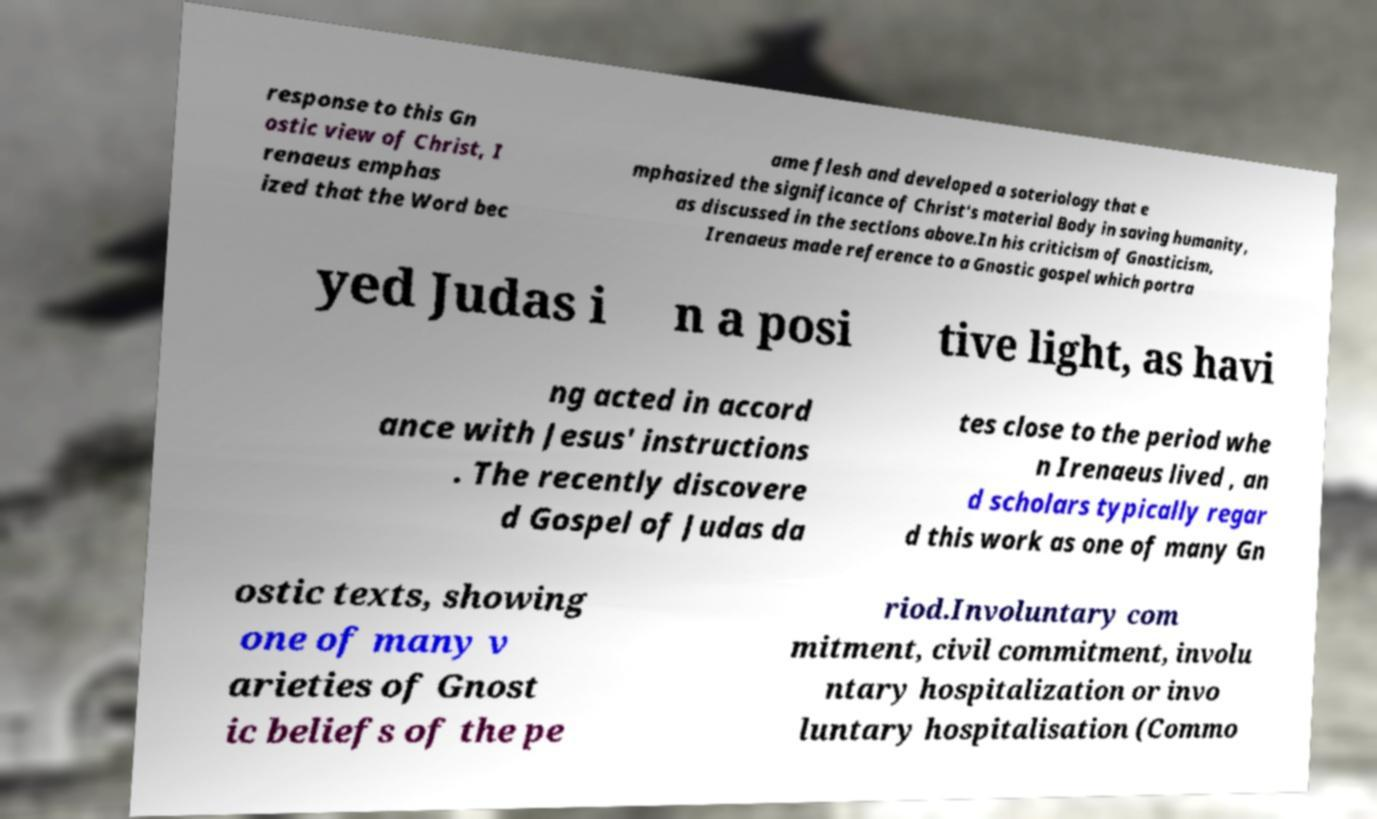I need the written content from this picture converted into text. Can you do that? response to this Gn ostic view of Christ, I renaeus emphas ized that the Word bec ame flesh and developed a soteriology that e mphasized the significance of Christ's material Body in saving humanity, as discussed in the sections above.In his criticism of Gnosticism, Irenaeus made reference to a Gnostic gospel which portra yed Judas i n a posi tive light, as havi ng acted in accord ance with Jesus' instructions . The recently discovere d Gospel of Judas da tes close to the period whe n Irenaeus lived , an d scholars typically regar d this work as one of many Gn ostic texts, showing one of many v arieties of Gnost ic beliefs of the pe riod.Involuntary com mitment, civil commitment, involu ntary hospitalization or invo luntary hospitalisation (Commo 